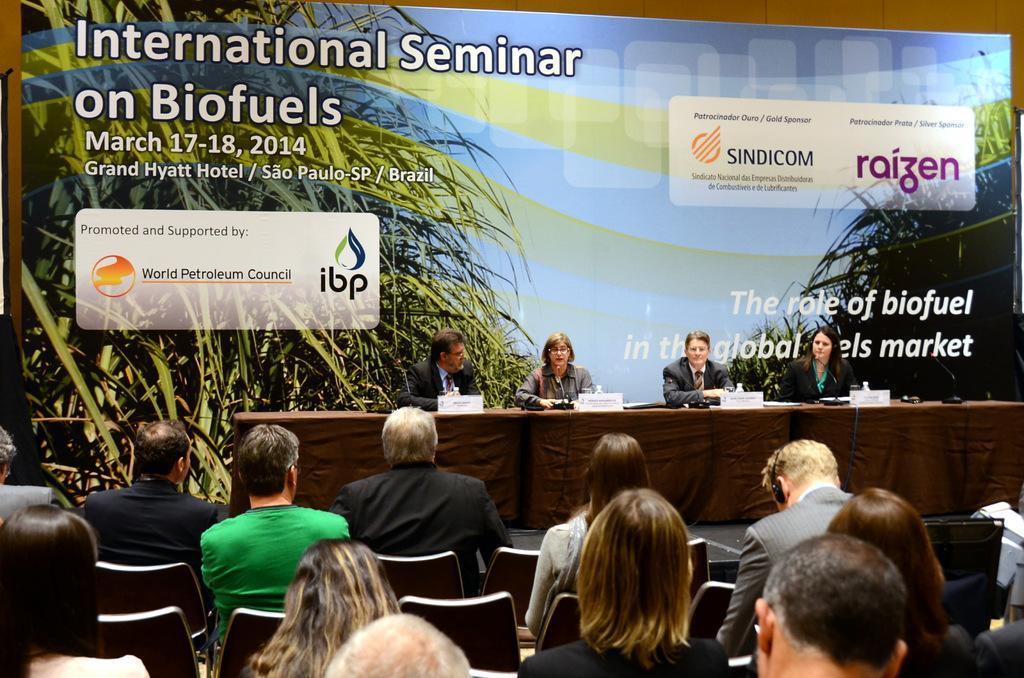Could you give a brief overview of what you see in this image? In this image, there are some person wearing clothes and sitting on chairs. There are four persons in the center of this image sitting in front of the table. These tables are covered with a cloth. There are some trees on the both sides of the image. 